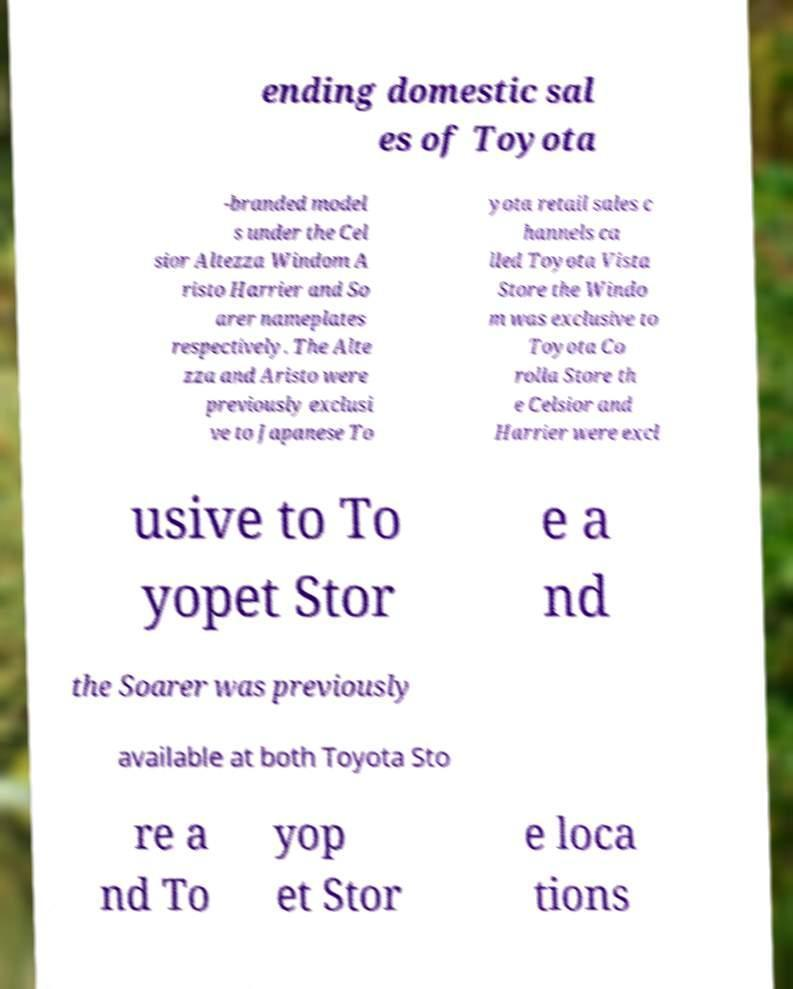Please read and relay the text visible in this image. What does it say? ending domestic sal es of Toyota -branded model s under the Cel sior Altezza Windom A risto Harrier and So arer nameplates respectively. The Alte zza and Aristo were previously exclusi ve to Japanese To yota retail sales c hannels ca lled Toyota Vista Store the Windo m was exclusive to Toyota Co rolla Store th e Celsior and Harrier were excl usive to To yopet Stor e a nd the Soarer was previously available at both Toyota Sto re a nd To yop et Stor e loca tions 